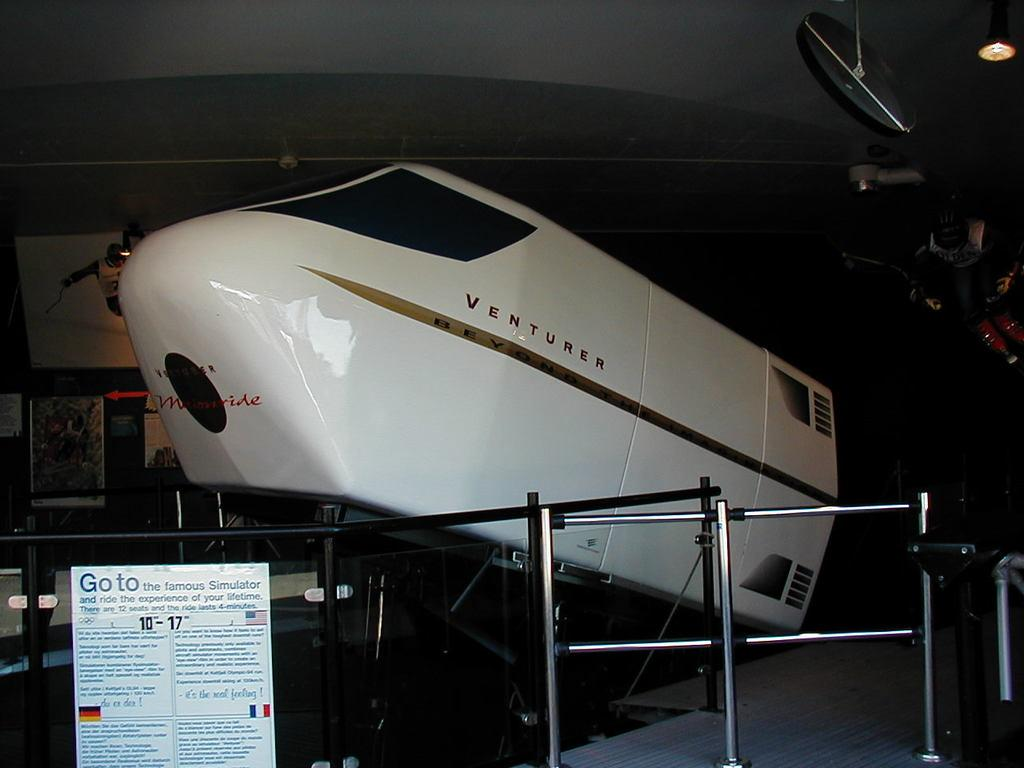Provide a one-sentence caption for the provided image. The word "VENTURER" is painted onto the airplane on display. 